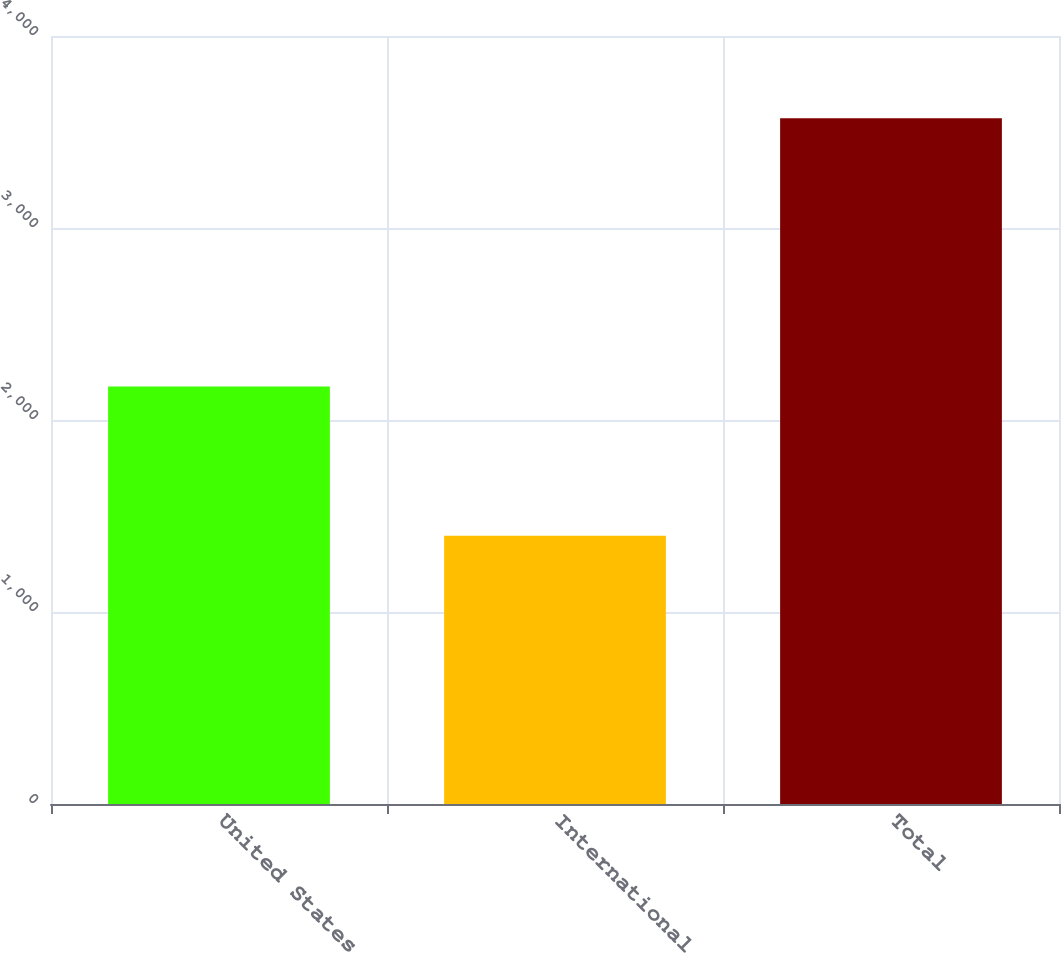Convert chart to OTSL. <chart><loc_0><loc_0><loc_500><loc_500><bar_chart><fcel>United States<fcel>International<fcel>Total<nl><fcel>2175<fcel>1397<fcel>3572<nl></chart> 